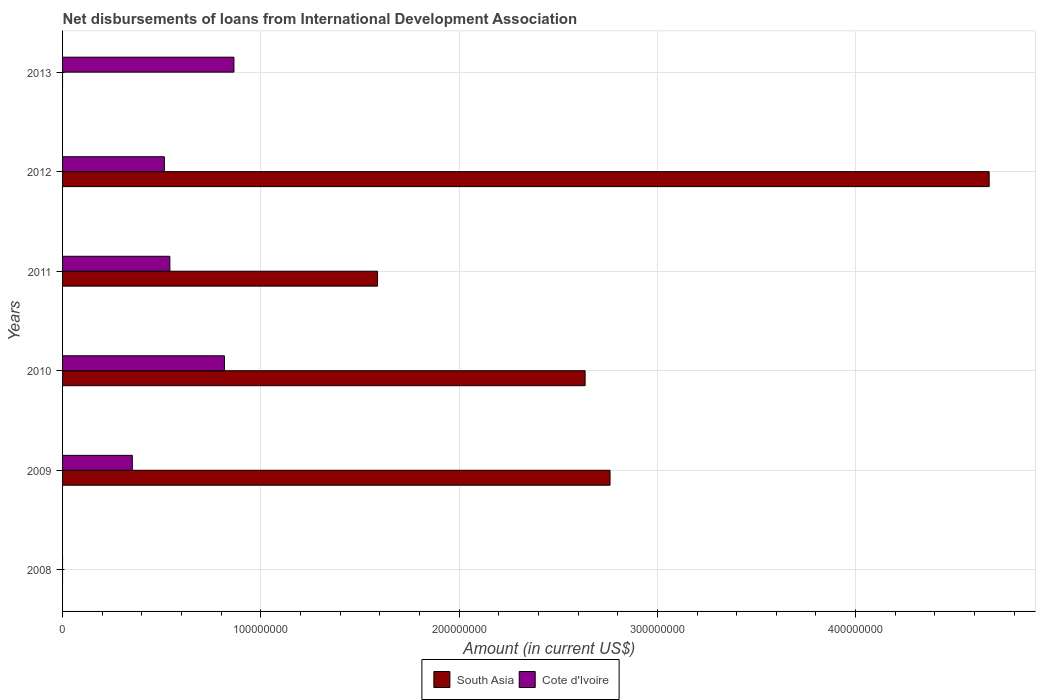Are the number of bars on each tick of the Y-axis equal?
Offer a very short reply. No. How many bars are there on the 4th tick from the top?
Keep it short and to the point. 2. How many bars are there on the 3rd tick from the bottom?
Keep it short and to the point. 2. What is the amount of loans disbursed in South Asia in 2013?
Offer a terse response. 0. Across all years, what is the maximum amount of loans disbursed in Cote d'Ivoire?
Give a very brief answer. 8.64e+07. In which year was the amount of loans disbursed in South Asia maximum?
Your answer should be very brief. 2012. What is the total amount of loans disbursed in South Asia in the graph?
Provide a short and direct response. 1.17e+09. What is the difference between the amount of loans disbursed in Cote d'Ivoire in 2009 and that in 2012?
Ensure brevity in your answer.  -1.62e+07. What is the difference between the amount of loans disbursed in South Asia in 2011 and the amount of loans disbursed in Cote d'Ivoire in 2012?
Keep it short and to the point. 1.08e+08. What is the average amount of loans disbursed in South Asia per year?
Provide a short and direct response. 1.94e+08. In the year 2011, what is the difference between the amount of loans disbursed in South Asia and amount of loans disbursed in Cote d'Ivoire?
Offer a very short reply. 1.05e+08. In how many years, is the amount of loans disbursed in South Asia greater than 20000000 US$?
Provide a short and direct response. 4. What is the ratio of the amount of loans disbursed in Cote d'Ivoire in 2012 to that in 2013?
Keep it short and to the point. 0.59. What is the difference between the highest and the second highest amount of loans disbursed in South Asia?
Provide a succinct answer. 1.91e+08. What is the difference between the highest and the lowest amount of loans disbursed in South Asia?
Your answer should be very brief. 4.67e+08. In how many years, is the amount of loans disbursed in Cote d'Ivoire greater than the average amount of loans disbursed in Cote d'Ivoire taken over all years?
Keep it short and to the point. 3. Is the sum of the amount of loans disbursed in Cote d'Ivoire in 2009 and 2012 greater than the maximum amount of loans disbursed in South Asia across all years?
Give a very brief answer. No. How many bars are there?
Your answer should be very brief. 9. How many years are there in the graph?
Your answer should be compact. 6. Are the values on the major ticks of X-axis written in scientific E-notation?
Offer a very short reply. No. Does the graph contain any zero values?
Provide a succinct answer. Yes. Does the graph contain grids?
Offer a terse response. Yes. Where does the legend appear in the graph?
Offer a very short reply. Bottom center. How many legend labels are there?
Ensure brevity in your answer.  2. How are the legend labels stacked?
Your answer should be very brief. Horizontal. What is the title of the graph?
Make the answer very short. Net disbursements of loans from International Development Association. What is the label or title of the X-axis?
Offer a terse response. Amount (in current US$). What is the Amount (in current US$) of South Asia in 2008?
Make the answer very short. 0. What is the Amount (in current US$) in South Asia in 2009?
Ensure brevity in your answer.  2.76e+08. What is the Amount (in current US$) in Cote d'Ivoire in 2009?
Offer a terse response. 3.52e+07. What is the Amount (in current US$) of South Asia in 2010?
Provide a short and direct response. 2.64e+08. What is the Amount (in current US$) of Cote d'Ivoire in 2010?
Your response must be concise. 8.16e+07. What is the Amount (in current US$) in South Asia in 2011?
Offer a terse response. 1.59e+08. What is the Amount (in current US$) in Cote d'Ivoire in 2011?
Ensure brevity in your answer.  5.41e+07. What is the Amount (in current US$) in South Asia in 2012?
Make the answer very short. 4.67e+08. What is the Amount (in current US$) in Cote d'Ivoire in 2012?
Your answer should be very brief. 5.13e+07. What is the Amount (in current US$) in Cote d'Ivoire in 2013?
Provide a succinct answer. 8.64e+07. Across all years, what is the maximum Amount (in current US$) of South Asia?
Provide a short and direct response. 4.67e+08. Across all years, what is the maximum Amount (in current US$) of Cote d'Ivoire?
Offer a terse response. 8.64e+07. Across all years, what is the minimum Amount (in current US$) in South Asia?
Give a very brief answer. 0. What is the total Amount (in current US$) of South Asia in the graph?
Give a very brief answer. 1.17e+09. What is the total Amount (in current US$) of Cote d'Ivoire in the graph?
Ensure brevity in your answer.  3.09e+08. What is the difference between the Amount (in current US$) of South Asia in 2009 and that in 2010?
Offer a terse response. 1.26e+07. What is the difference between the Amount (in current US$) of Cote d'Ivoire in 2009 and that in 2010?
Make the answer very short. -4.65e+07. What is the difference between the Amount (in current US$) in South Asia in 2009 and that in 2011?
Your answer should be compact. 1.17e+08. What is the difference between the Amount (in current US$) in Cote d'Ivoire in 2009 and that in 2011?
Your answer should be compact. -1.89e+07. What is the difference between the Amount (in current US$) in South Asia in 2009 and that in 2012?
Make the answer very short. -1.91e+08. What is the difference between the Amount (in current US$) in Cote d'Ivoire in 2009 and that in 2012?
Your answer should be compact. -1.62e+07. What is the difference between the Amount (in current US$) of Cote d'Ivoire in 2009 and that in 2013?
Offer a very short reply. -5.12e+07. What is the difference between the Amount (in current US$) of South Asia in 2010 and that in 2011?
Provide a short and direct response. 1.05e+08. What is the difference between the Amount (in current US$) of Cote d'Ivoire in 2010 and that in 2011?
Ensure brevity in your answer.  2.75e+07. What is the difference between the Amount (in current US$) in South Asia in 2010 and that in 2012?
Offer a terse response. -2.04e+08. What is the difference between the Amount (in current US$) in Cote d'Ivoire in 2010 and that in 2012?
Your response must be concise. 3.03e+07. What is the difference between the Amount (in current US$) of Cote d'Ivoire in 2010 and that in 2013?
Your answer should be very brief. -4.78e+06. What is the difference between the Amount (in current US$) of South Asia in 2011 and that in 2012?
Ensure brevity in your answer.  -3.08e+08. What is the difference between the Amount (in current US$) of Cote d'Ivoire in 2011 and that in 2012?
Your answer should be compact. 2.77e+06. What is the difference between the Amount (in current US$) in Cote d'Ivoire in 2011 and that in 2013?
Give a very brief answer. -3.23e+07. What is the difference between the Amount (in current US$) of Cote d'Ivoire in 2012 and that in 2013?
Provide a succinct answer. -3.51e+07. What is the difference between the Amount (in current US$) of South Asia in 2009 and the Amount (in current US$) of Cote d'Ivoire in 2010?
Your answer should be compact. 1.94e+08. What is the difference between the Amount (in current US$) of South Asia in 2009 and the Amount (in current US$) of Cote d'Ivoire in 2011?
Offer a terse response. 2.22e+08. What is the difference between the Amount (in current US$) of South Asia in 2009 and the Amount (in current US$) of Cote d'Ivoire in 2012?
Ensure brevity in your answer.  2.25e+08. What is the difference between the Amount (in current US$) in South Asia in 2009 and the Amount (in current US$) in Cote d'Ivoire in 2013?
Offer a terse response. 1.90e+08. What is the difference between the Amount (in current US$) of South Asia in 2010 and the Amount (in current US$) of Cote d'Ivoire in 2011?
Your answer should be compact. 2.09e+08. What is the difference between the Amount (in current US$) in South Asia in 2010 and the Amount (in current US$) in Cote d'Ivoire in 2012?
Your answer should be compact. 2.12e+08. What is the difference between the Amount (in current US$) of South Asia in 2010 and the Amount (in current US$) of Cote d'Ivoire in 2013?
Offer a terse response. 1.77e+08. What is the difference between the Amount (in current US$) in South Asia in 2011 and the Amount (in current US$) in Cote d'Ivoire in 2012?
Keep it short and to the point. 1.08e+08. What is the difference between the Amount (in current US$) of South Asia in 2011 and the Amount (in current US$) of Cote d'Ivoire in 2013?
Your response must be concise. 7.24e+07. What is the difference between the Amount (in current US$) of South Asia in 2012 and the Amount (in current US$) of Cote d'Ivoire in 2013?
Your answer should be very brief. 3.81e+08. What is the average Amount (in current US$) in South Asia per year?
Make the answer very short. 1.94e+08. What is the average Amount (in current US$) in Cote d'Ivoire per year?
Provide a short and direct response. 5.14e+07. In the year 2009, what is the difference between the Amount (in current US$) of South Asia and Amount (in current US$) of Cote d'Ivoire?
Make the answer very short. 2.41e+08. In the year 2010, what is the difference between the Amount (in current US$) in South Asia and Amount (in current US$) in Cote d'Ivoire?
Ensure brevity in your answer.  1.82e+08. In the year 2011, what is the difference between the Amount (in current US$) in South Asia and Amount (in current US$) in Cote d'Ivoire?
Your response must be concise. 1.05e+08. In the year 2012, what is the difference between the Amount (in current US$) in South Asia and Amount (in current US$) in Cote d'Ivoire?
Ensure brevity in your answer.  4.16e+08. What is the ratio of the Amount (in current US$) of South Asia in 2009 to that in 2010?
Provide a succinct answer. 1.05. What is the ratio of the Amount (in current US$) of Cote d'Ivoire in 2009 to that in 2010?
Provide a short and direct response. 0.43. What is the ratio of the Amount (in current US$) of South Asia in 2009 to that in 2011?
Make the answer very short. 1.74. What is the ratio of the Amount (in current US$) in Cote d'Ivoire in 2009 to that in 2011?
Make the answer very short. 0.65. What is the ratio of the Amount (in current US$) in South Asia in 2009 to that in 2012?
Your response must be concise. 0.59. What is the ratio of the Amount (in current US$) in Cote d'Ivoire in 2009 to that in 2012?
Offer a terse response. 0.69. What is the ratio of the Amount (in current US$) in Cote d'Ivoire in 2009 to that in 2013?
Your answer should be compact. 0.41. What is the ratio of the Amount (in current US$) of South Asia in 2010 to that in 2011?
Your answer should be very brief. 1.66. What is the ratio of the Amount (in current US$) in Cote d'Ivoire in 2010 to that in 2011?
Your response must be concise. 1.51. What is the ratio of the Amount (in current US$) of South Asia in 2010 to that in 2012?
Your answer should be very brief. 0.56. What is the ratio of the Amount (in current US$) of Cote d'Ivoire in 2010 to that in 2012?
Your answer should be very brief. 1.59. What is the ratio of the Amount (in current US$) of Cote d'Ivoire in 2010 to that in 2013?
Your response must be concise. 0.94. What is the ratio of the Amount (in current US$) of South Asia in 2011 to that in 2012?
Provide a short and direct response. 0.34. What is the ratio of the Amount (in current US$) of Cote d'Ivoire in 2011 to that in 2012?
Your answer should be compact. 1.05. What is the ratio of the Amount (in current US$) in Cote d'Ivoire in 2011 to that in 2013?
Your answer should be very brief. 0.63. What is the ratio of the Amount (in current US$) of Cote d'Ivoire in 2012 to that in 2013?
Ensure brevity in your answer.  0.59. What is the difference between the highest and the second highest Amount (in current US$) in South Asia?
Provide a succinct answer. 1.91e+08. What is the difference between the highest and the second highest Amount (in current US$) of Cote d'Ivoire?
Make the answer very short. 4.78e+06. What is the difference between the highest and the lowest Amount (in current US$) in South Asia?
Give a very brief answer. 4.67e+08. What is the difference between the highest and the lowest Amount (in current US$) in Cote d'Ivoire?
Provide a short and direct response. 8.64e+07. 